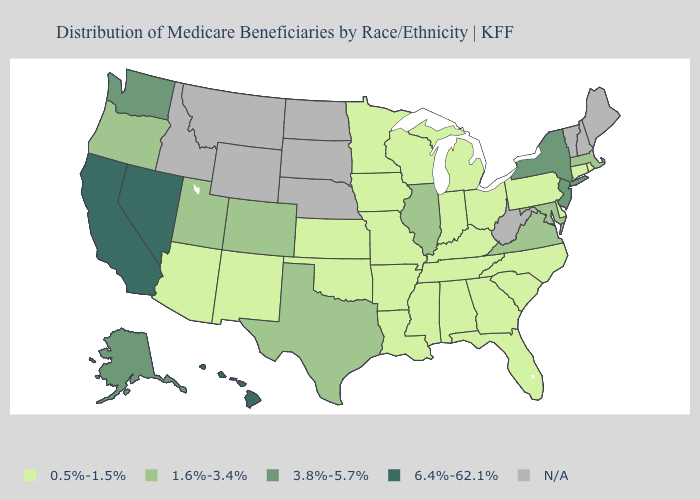What is the highest value in the USA?
Give a very brief answer. 6.4%-62.1%. What is the highest value in the South ?
Short answer required. 1.6%-3.4%. Among the states that border California , does Arizona have the lowest value?
Short answer required. Yes. What is the value of New Hampshire?
Concise answer only. N/A. Does the map have missing data?
Concise answer only. Yes. What is the highest value in the USA?
Keep it brief. 6.4%-62.1%. Does Utah have the lowest value in the USA?
Write a very short answer. No. Does the map have missing data?
Keep it brief. Yes. What is the highest value in states that border Arizona?
Quick response, please. 6.4%-62.1%. Name the states that have a value in the range 1.6%-3.4%?
Give a very brief answer. Colorado, Illinois, Maryland, Massachusetts, Oregon, Texas, Utah, Virginia. Among the states that border Florida , which have the highest value?
Concise answer only. Alabama, Georgia. What is the value of New Hampshire?
Keep it brief. N/A. Does the first symbol in the legend represent the smallest category?
Answer briefly. Yes. What is the value of Minnesota?
Write a very short answer. 0.5%-1.5%. Which states hav the highest value in the Northeast?
Write a very short answer. New Jersey, New York. 